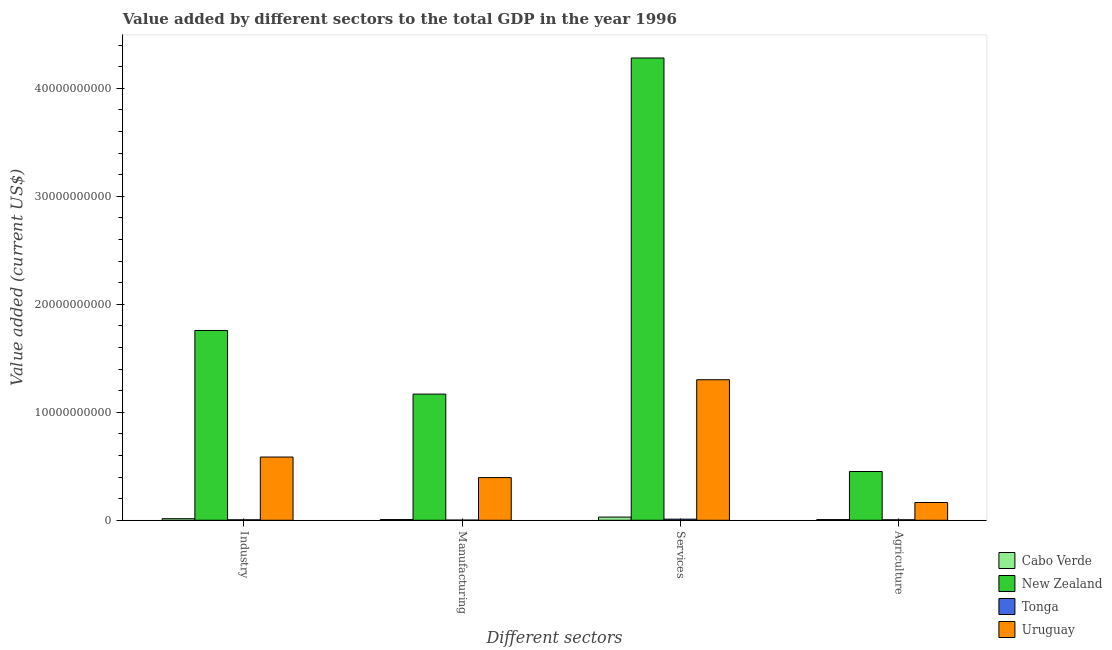How many groups of bars are there?
Give a very brief answer. 4. Are the number of bars on each tick of the X-axis equal?
Offer a very short reply. Yes. What is the label of the 1st group of bars from the left?
Make the answer very short. Industry. What is the value added by services sector in Tonga?
Provide a succinct answer. 1.03e+08. Across all countries, what is the maximum value added by agricultural sector?
Provide a short and direct response. 4.52e+09. Across all countries, what is the minimum value added by manufacturing sector?
Your response must be concise. 1.71e+07. In which country was the value added by agricultural sector maximum?
Your answer should be compact. New Zealand. In which country was the value added by agricultural sector minimum?
Ensure brevity in your answer.  Tonga. What is the total value added by industrial sector in the graph?
Keep it short and to the point. 2.36e+1. What is the difference between the value added by industrial sector in New Zealand and that in Tonga?
Provide a short and direct response. 1.75e+1. What is the difference between the value added by manufacturing sector in Cabo Verde and the value added by industrial sector in Tonga?
Make the answer very short. 2.31e+07. What is the average value added by agricultural sector per country?
Offer a terse response. 1.57e+09. What is the difference between the value added by services sector and value added by agricultural sector in Cabo Verde?
Offer a terse response. 2.32e+08. In how many countries, is the value added by industrial sector greater than 42000000000 US$?
Your answer should be compact. 0. What is the ratio of the value added by agricultural sector in Tonga to that in Uruguay?
Offer a terse response. 0.03. Is the value added by services sector in Uruguay less than that in Cabo Verde?
Provide a short and direct response. No. What is the difference between the highest and the second highest value added by industrial sector?
Your response must be concise. 1.17e+1. What is the difference between the highest and the lowest value added by services sector?
Provide a succinct answer. 4.27e+1. Is the sum of the value added by industrial sector in Tonga and Uruguay greater than the maximum value added by manufacturing sector across all countries?
Keep it short and to the point. No. Is it the case that in every country, the sum of the value added by agricultural sector and value added by services sector is greater than the sum of value added by manufacturing sector and value added by industrial sector?
Provide a succinct answer. No. What does the 3rd bar from the left in Manufacturing represents?
Offer a very short reply. Tonga. What does the 1st bar from the right in Manufacturing represents?
Make the answer very short. Uruguay. Is it the case that in every country, the sum of the value added by industrial sector and value added by manufacturing sector is greater than the value added by services sector?
Keep it short and to the point. No. How many bars are there?
Keep it short and to the point. 16. Are all the bars in the graph horizontal?
Your response must be concise. No. Are the values on the major ticks of Y-axis written in scientific E-notation?
Give a very brief answer. No. Does the graph contain grids?
Your response must be concise. No. Where does the legend appear in the graph?
Make the answer very short. Bottom right. How many legend labels are there?
Your answer should be compact. 4. How are the legend labels stacked?
Provide a succinct answer. Vertical. What is the title of the graph?
Offer a terse response. Value added by different sectors to the total GDP in the year 1996. Does "Lao PDR" appear as one of the legend labels in the graph?
Provide a succinct answer. No. What is the label or title of the X-axis?
Provide a succinct answer. Different sectors. What is the label or title of the Y-axis?
Ensure brevity in your answer.  Value added (current US$). What is the Value added (current US$) of Cabo Verde in Industry?
Your response must be concise. 1.45e+08. What is the Value added (current US$) of New Zealand in Industry?
Your response must be concise. 1.76e+1. What is the Value added (current US$) of Tonga in Industry?
Make the answer very short. 4.25e+07. What is the Value added (current US$) of Uruguay in Industry?
Provide a succinct answer. 5.86e+09. What is the Value added (current US$) of Cabo Verde in Manufacturing?
Give a very brief answer. 6.55e+07. What is the Value added (current US$) of New Zealand in Manufacturing?
Provide a succinct answer. 1.17e+1. What is the Value added (current US$) of Tonga in Manufacturing?
Your response must be concise. 1.71e+07. What is the Value added (current US$) of Uruguay in Manufacturing?
Your response must be concise. 3.95e+09. What is the Value added (current US$) in Cabo Verde in Services?
Offer a very short reply. 2.94e+08. What is the Value added (current US$) in New Zealand in Services?
Your answer should be compact. 4.28e+1. What is the Value added (current US$) of Tonga in Services?
Offer a terse response. 1.03e+08. What is the Value added (current US$) of Uruguay in Services?
Keep it short and to the point. 1.30e+1. What is the Value added (current US$) in Cabo Verde in Agriculture?
Ensure brevity in your answer.  6.25e+07. What is the Value added (current US$) in New Zealand in Agriculture?
Provide a short and direct response. 4.52e+09. What is the Value added (current US$) in Tonga in Agriculture?
Offer a terse response. 4.53e+07. What is the Value added (current US$) in Uruguay in Agriculture?
Provide a succinct answer. 1.64e+09. Across all Different sectors, what is the maximum Value added (current US$) of Cabo Verde?
Your answer should be compact. 2.94e+08. Across all Different sectors, what is the maximum Value added (current US$) in New Zealand?
Offer a terse response. 4.28e+1. Across all Different sectors, what is the maximum Value added (current US$) in Tonga?
Offer a terse response. 1.03e+08. Across all Different sectors, what is the maximum Value added (current US$) of Uruguay?
Ensure brevity in your answer.  1.30e+1. Across all Different sectors, what is the minimum Value added (current US$) of Cabo Verde?
Offer a very short reply. 6.25e+07. Across all Different sectors, what is the minimum Value added (current US$) of New Zealand?
Keep it short and to the point. 4.52e+09. Across all Different sectors, what is the minimum Value added (current US$) of Tonga?
Provide a short and direct response. 1.71e+07. Across all Different sectors, what is the minimum Value added (current US$) in Uruguay?
Your answer should be very brief. 1.64e+09. What is the total Value added (current US$) in Cabo Verde in the graph?
Ensure brevity in your answer.  5.68e+08. What is the total Value added (current US$) in New Zealand in the graph?
Your answer should be very brief. 7.66e+1. What is the total Value added (current US$) in Tonga in the graph?
Your response must be concise. 2.07e+08. What is the total Value added (current US$) of Uruguay in the graph?
Keep it short and to the point. 2.45e+1. What is the difference between the Value added (current US$) of Cabo Verde in Industry and that in Manufacturing?
Keep it short and to the point. 7.97e+07. What is the difference between the Value added (current US$) of New Zealand in Industry and that in Manufacturing?
Give a very brief answer. 5.89e+09. What is the difference between the Value added (current US$) of Tonga in Industry and that in Manufacturing?
Keep it short and to the point. 2.53e+07. What is the difference between the Value added (current US$) in Uruguay in Industry and that in Manufacturing?
Provide a short and direct response. 1.90e+09. What is the difference between the Value added (current US$) of Cabo Verde in Industry and that in Services?
Provide a short and direct response. -1.49e+08. What is the difference between the Value added (current US$) of New Zealand in Industry and that in Services?
Keep it short and to the point. -2.52e+1. What is the difference between the Value added (current US$) of Tonga in Industry and that in Services?
Ensure brevity in your answer.  -6.02e+07. What is the difference between the Value added (current US$) of Uruguay in Industry and that in Services?
Offer a very short reply. -7.16e+09. What is the difference between the Value added (current US$) of Cabo Verde in Industry and that in Agriculture?
Provide a succinct answer. 8.27e+07. What is the difference between the Value added (current US$) of New Zealand in Industry and that in Agriculture?
Your answer should be very brief. 1.31e+1. What is the difference between the Value added (current US$) of Tonga in Industry and that in Agriculture?
Offer a very short reply. -2.80e+06. What is the difference between the Value added (current US$) in Uruguay in Industry and that in Agriculture?
Your answer should be very brief. 4.21e+09. What is the difference between the Value added (current US$) in Cabo Verde in Manufacturing and that in Services?
Provide a succinct answer. -2.29e+08. What is the difference between the Value added (current US$) in New Zealand in Manufacturing and that in Services?
Give a very brief answer. -3.11e+1. What is the difference between the Value added (current US$) of Tonga in Manufacturing and that in Services?
Offer a terse response. -8.55e+07. What is the difference between the Value added (current US$) of Uruguay in Manufacturing and that in Services?
Make the answer very short. -9.06e+09. What is the difference between the Value added (current US$) of Cabo Verde in Manufacturing and that in Agriculture?
Provide a short and direct response. 3.05e+06. What is the difference between the Value added (current US$) in New Zealand in Manufacturing and that in Agriculture?
Provide a succinct answer. 7.17e+09. What is the difference between the Value added (current US$) in Tonga in Manufacturing and that in Agriculture?
Provide a short and direct response. -2.82e+07. What is the difference between the Value added (current US$) in Uruguay in Manufacturing and that in Agriculture?
Offer a terse response. 2.31e+09. What is the difference between the Value added (current US$) in Cabo Verde in Services and that in Agriculture?
Provide a succinct answer. 2.32e+08. What is the difference between the Value added (current US$) of New Zealand in Services and that in Agriculture?
Ensure brevity in your answer.  3.83e+1. What is the difference between the Value added (current US$) in Tonga in Services and that in Agriculture?
Give a very brief answer. 5.74e+07. What is the difference between the Value added (current US$) of Uruguay in Services and that in Agriculture?
Your answer should be very brief. 1.14e+1. What is the difference between the Value added (current US$) of Cabo Verde in Industry and the Value added (current US$) of New Zealand in Manufacturing?
Give a very brief answer. -1.15e+1. What is the difference between the Value added (current US$) in Cabo Verde in Industry and the Value added (current US$) in Tonga in Manufacturing?
Provide a succinct answer. 1.28e+08. What is the difference between the Value added (current US$) of Cabo Verde in Industry and the Value added (current US$) of Uruguay in Manufacturing?
Offer a very short reply. -3.81e+09. What is the difference between the Value added (current US$) of New Zealand in Industry and the Value added (current US$) of Tonga in Manufacturing?
Offer a terse response. 1.76e+1. What is the difference between the Value added (current US$) in New Zealand in Industry and the Value added (current US$) in Uruguay in Manufacturing?
Offer a terse response. 1.36e+1. What is the difference between the Value added (current US$) in Tonga in Industry and the Value added (current US$) in Uruguay in Manufacturing?
Provide a short and direct response. -3.91e+09. What is the difference between the Value added (current US$) of Cabo Verde in Industry and the Value added (current US$) of New Zealand in Services?
Offer a very short reply. -4.27e+1. What is the difference between the Value added (current US$) in Cabo Verde in Industry and the Value added (current US$) in Tonga in Services?
Offer a very short reply. 4.26e+07. What is the difference between the Value added (current US$) in Cabo Verde in Industry and the Value added (current US$) in Uruguay in Services?
Provide a succinct answer. -1.29e+1. What is the difference between the Value added (current US$) in New Zealand in Industry and the Value added (current US$) in Tonga in Services?
Provide a succinct answer. 1.75e+1. What is the difference between the Value added (current US$) of New Zealand in Industry and the Value added (current US$) of Uruguay in Services?
Offer a very short reply. 4.56e+09. What is the difference between the Value added (current US$) in Tonga in Industry and the Value added (current US$) in Uruguay in Services?
Your answer should be compact. -1.30e+1. What is the difference between the Value added (current US$) in Cabo Verde in Industry and the Value added (current US$) in New Zealand in Agriculture?
Provide a succinct answer. -4.37e+09. What is the difference between the Value added (current US$) of Cabo Verde in Industry and the Value added (current US$) of Tonga in Agriculture?
Your response must be concise. 1.00e+08. What is the difference between the Value added (current US$) of Cabo Verde in Industry and the Value added (current US$) of Uruguay in Agriculture?
Offer a terse response. -1.50e+09. What is the difference between the Value added (current US$) of New Zealand in Industry and the Value added (current US$) of Tonga in Agriculture?
Keep it short and to the point. 1.75e+1. What is the difference between the Value added (current US$) of New Zealand in Industry and the Value added (current US$) of Uruguay in Agriculture?
Make the answer very short. 1.59e+1. What is the difference between the Value added (current US$) of Tonga in Industry and the Value added (current US$) of Uruguay in Agriculture?
Your answer should be very brief. -1.60e+09. What is the difference between the Value added (current US$) in Cabo Verde in Manufacturing and the Value added (current US$) in New Zealand in Services?
Your answer should be compact. -4.27e+1. What is the difference between the Value added (current US$) of Cabo Verde in Manufacturing and the Value added (current US$) of Tonga in Services?
Offer a very short reply. -3.71e+07. What is the difference between the Value added (current US$) in Cabo Verde in Manufacturing and the Value added (current US$) in Uruguay in Services?
Your response must be concise. -1.29e+1. What is the difference between the Value added (current US$) of New Zealand in Manufacturing and the Value added (current US$) of Tonga in Services?
Make the answer very short. 1.16e+1. What is the difference between the Value added (current US$) in New Zealand in Manufacturing and the Value added (current US$) in Uruguay in Services?
Provide a succinct answer. -1.33e+09. What is the difference between the Value added (current US$) in Tonga in Manufacturing and the Value added (current US$) in Uruguay in Services?
Your answer should be compact. -1.30e+1. What is the difference between the Value added (current US$) of Cabo Verde in Manufacturing and the Value added (current US$) of New Zealand in Agriculture?
Make the answer very short. -4.45e+09. What is the difference between the Value added (current US$) of Cabo Verde in Manufacturing and the Value added (current US$) of Tonga in Agriculture?
Your response must be concise. 2.03e+07. What is the difference between the Value added (current US$) of Cabo Verde in Manufacturing and the Value added (current US$) of Uruguay in Agriculture?
Provide a succinct answer. -1.58e+09. What is the difference between the Value added (current US$) in New Zealand in Manufacturing and the Value added (current US$) in Tonga in Agriculture?
Ensure brevity in your answer.  1.16e+1. What is the difference between the Value added (current US$) in New Zealand in Manufacturing and the Value added (current US$) in Uruguay in Agriculture?
Ensure brevity in your answer.  1.00e+1. What is the difference between the Value added (current US$) in Tonga in Manufacturing and the Value added (current US$) in Uruguay in Agriculture?
Your answer should be very brief. -1.63e+09. What is the difference between the Value added (current US$) of Cabo Verde in Services and the Value added (current US$) of New Zealand in Agriculture?
Make the answer very short. -4.22e+09. What is the difference between the Value added (current US$) of Cabo Verde in Services and the Value added (current US$) of Tonga in Agriculture?
Offer a very short reply. 2.49e+08. What is the difference between the Value added (current US$) in Cabo Verde in Services and the Value added (current US$) in Uruguay in Agriculture?
Provide a short and direct response. -1.35e+09. What is the difference between the Value added (current US$) of New Zealand in Services and the Value added (current US$) of Tonga in Agriculture?
Provide a succinct answer. 4.28e+1. What is the difference between the Value added (current US$) in New Zealand in Services and the Value added (current US$) in Uruguay in Agriculture?
Offer a very short reply. 4.12e+1. What is the difference between the Value added (current US$) in Tonga in Services and the Value added (current US$) in Uruguay in Agriculture?
Provide a short and direct response. -1.54e+09. What is the average Value added (current US$) in Cabo Verde per Different sectors?
Offer a terse response. 1.42e+08. What is the average Value added (current US$) of New Zealand per Different sectors?
Provide a short and direct response. 1.91e+1. What is the average Value added (current US$) of Tonga per Different sectors?
Provide a succinct answer. 5.19e+07. What is the average Value added (current US$) of Uruguay per Different sectors?
Offer a very short reply. 6.12e+09. What is the difference between the Value added (current US$) of Cabo Verde and Value added (current US$) of New Zealand in Industry?
Give a very brief answer. -1.74e+1. What is the difference between the Value added (current US$) of Cabo Verde and Value added (current US$) of Tonga in Industry?
Your answer should be compact. 1.03e+08. What is the difference between the Value added (current US$) of Cabo Verde and Value added (current US$) of Uruguay in Industry?
Your answer should be compact. -5.71e+09. What is the difference between the Value added (current US$) of New Zealand and Value added (current US$) of Tonga in Industry?
Offer a very short reply. 1.75e+1. What is the difference between the Value added (current US$) of New Zealand and Value added (current US$) of Uruguay in Industry?
Provide a succinct answer. 1.17e+1. What is the difference between the Value added (current US$) of Tonga and Value added (current US$) of Uruguay in Industry?
Provide a short and direct response. -5.81e+09. What is the difference between the Value added (current US$) in Cabo Verde and Value added (current US$) in New Zealand in Manufacturing?
Ensure brevity in your answer.  -1.16e+1. What is the difference between the Value added (current US$) of Cabo Verde and Value added (current US$) of Tonga in Manufacturing?
Ensure brevity in your answer.  4.84e+07. What is the difference between the Value added (current US$) in Cabo Verde and Value added (current US$) in Uruguay in Manufacturing?
Your answer should be very brief. -3.89e+09. What is the difference between the Value added (current US$) of New Zealand and Value added (current US$) of Tonga in Manufacturing?
Offer a very short reply. 1.17e+1. What is the difference between the Value added (current US$) of New Zealand and Value added (current US$) of Uruguay in Manufacturing?
Your answer should be very brief. 7.73e+09. What is the difference between the Value added (current US$) of Tonga and Value added (current US$) of Uruguay in Manufacturing?
Provide a short and direct response. -3.93e+09. What is the difference between the Value added (current US$) in Cabo Verde and Value added (current US$) in New Zealand in Services?
Ensure brevity in your answer.  -4.25e+1. What is the difference between the Value added (current US$) in Cabo Verde and Value added (current US$) in Tonga in Services?
Your response must be concise. 1.92e+08. What is the difference between the Value added (current US$) in Cabo Verde and Value added (current US$) in Uruguay in Services?
Offer a very short reply. -1.27e+1. What is the difference between the Value added (current US$) of New Zealand and Value added (current US$) of Tonga in Services?
Offer a terse response. 4.27e+1. What is the difference between the Value added (current US$) of New Zealand and Value added (current US$) of Uruguay in Services?
Offer a very short reply. 2.98e+1. What is the difference between the Value added (current US$) in Tonga and Value added (current US$) in Uruguay in Services?
Your response must be concise. -1.29e+1. What is the difference between the Value added (current US$) of Cabo Verde and Value added (current US$) of New Zealand in Agriculture?
Keep it short and to the point. -4.45e+09. What is the difference between the Value added (current US$) of Cabo Verde and Value added (current US$) of Tonga in Agriculture?
Your answer should be compact. 1.72e+07. What is the difference between the Value added (current US$) in Cabo Verde and Value added (current US$) in Uruguay in Agriculture?
Your response must be concise. -1.58e+09. What is the difference between the Value added (current US$) in New Zealand and Value added (current US$) in Tonga in Agriculture?
Offer a very short reply. 4.47e+09. What is the difference between the Value added (current US$) of New Zealand and Value added (current US$) of Uruguay in Agriculture?
Ensure brevity in your answer.  2.87e+09. What is the difference between the Value added (current US$) in Tonga and Value added (current US$) in Uruguay in Agriculture?
Offer a very short reply. -1.60e+09. What is the ratio of the Value added (current US$) in Cabo Verde in Industry to that in Manufacturing?
Offer a very short reply. 2.22. What is the ratio of the Value added (current US$) in New Zealand in Industry to that in Manufacturing?
Your answer should be very brief. 1.5. What is the ratio of the Value added (current US$) in Tonga in Industry to that in Manufacturing?
Provide a short and direct response. 2.48. What is the ratio of the Value added (current US$) of Uruguay in Industry to that in Manufacturing?
Offer a terse response. 1.48. What is the ratio of the Value added (current US$) in Cabo Verde in Industry to that in Services?
Provide a succinct answer. 0.49. What is the ratio of the Value added (current US$) of New Zealand in Industry to that in Services?
Your answer should be compact. 0.41. What is the ratio of the Value added (current US$) of Tonga in Industry to that in Services?
Offer a terse response. 0.41. What is the ratio of the Value added (current US$) of Uruguay in Industry to that in Services?
Make the answer very short. 0.45. What is the ratio of the Value added (current US$) in Cabo Verde in Industry to that in Agriculture?
Offer a very short reply. 2.32. What is the ratio of the Value added (current US$) in New Zealand in Industry to that in Agriculture?
Provide a short and direct response. 3.89. What is the ratio of the Value added (current US$) in Tonga in Industry to that in Agriculture?
Give a very brief answer. 0.94. What is the ratio of the Value added (current US$) of Uruguay in Industry to that in Agriculture?
Ensure brevity in your answer.  3.56. What is the ratio of the Value added (current US$) in Cabo Verde in Manufacturing to that in Services?
Offer a very short reply. 0.22. What is the ratio of the Value added (current US$) of New Zealand in Manufacturing to that in Services?
Make the answer very short. 0.27. What is the ratio of the Value added (current US$) in Tonga in Manufacturing to that in Services?
Your response must be concise. 0.17. What is the ratio of the Value added (current US$) in Uruguay in Manufacturing to that in Services?
Your response must be concise. 0.3. What is the ratio of the Value added (current US$) of Cabo Verde in Manufacturing to that in Agriculture?
Provide a succinct answer. 1.05. What is the ratio of the Value added (current US$) in New Zealand in Manufacturing to that in Agriculture?
Your response must be concise. 2.59. What is the ratio of the Value added (current US$) of Tonga in Manufacturing to that in Agriculture?
Offer a very short reply. 0.38. What is the ratio of the Value added (current US$) of Uruguay in Manufacturing to that in Agriculture?
Ensure brevity in your answer.  2.4. What is the ratio of the Value added (current US$) in Cabo Verde in Services to that in Agriculture?
Ensure brevity in your answer.  4.71. What is the ratio of the Value added (current US$) in New Zealand in Services to that in Agriculture?
Provide a short and direct response. 9.48. What is the ratio of the Value added (current US$) of Tonga in Services to that in Agriculture?
Ensure brevity in your answer.  2.27. What is the ratio of the Value added (current US$) in Uruguay in Services to that in Agriculture?
Make the answer very short. 7.91. What is the difference between the highest and the second highest Value added (current US$) in Cabo Verde?
Give a very brief answer. 1.49e+08. What is the difference between the highest and the second highest Value added (current US$) in New Zealand?
Provide a short and direct response. 2.52e+1. What is the difference between the highest and the second highest Value added (current US$) of Tonga?
Provide a short and direct response. 5.74e+07. What is the difference between the highest and the second highest Value added (current US$) of Uruguay?
Provide a succinct answer. 7.16e+09. What is the difference between the highest and the lowest Value added (current US$) in Cabo Verde?
Provide a short and direct response. 2.32e+08. What is the difference between the highest and the lowest Value added (current US$) of New Zealand?
Make the answer very short. 3.83e+1. What is the difference between the highest and the lowest Value added (current US$) in Tonga?
Give a very brief answer. 8.55e+07. What is the difference between the highest and the lowest Value added (current US$) in Uruguay?
Your answer should be compact. 1.14e+1. 